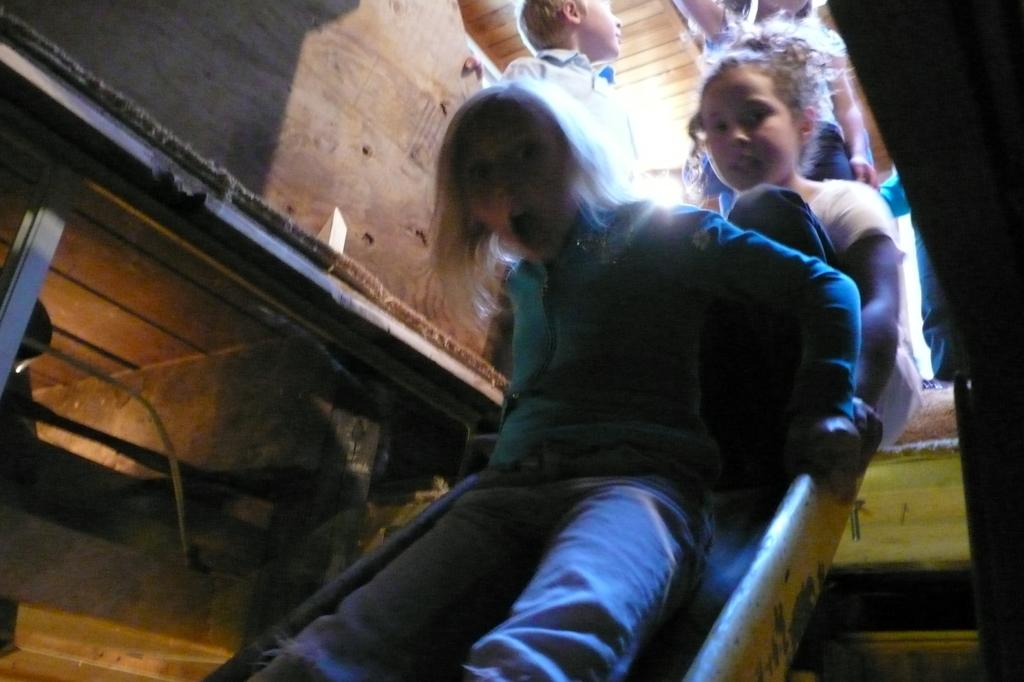What are the children in the image doing? The children are playing in the image. Where are the children playing? The children are playing on a slope. Can you describe the person in the image? The person in the image is wearing a t-shirt and trousers. What is the house in the image made of? The house in the image is made of wood. What type of baseball equipment can be seen in the image? There is no baseball equipment present in the image. What kind of needlework is the laborer doing in the image? There is no laborer or needlework present in the image. 